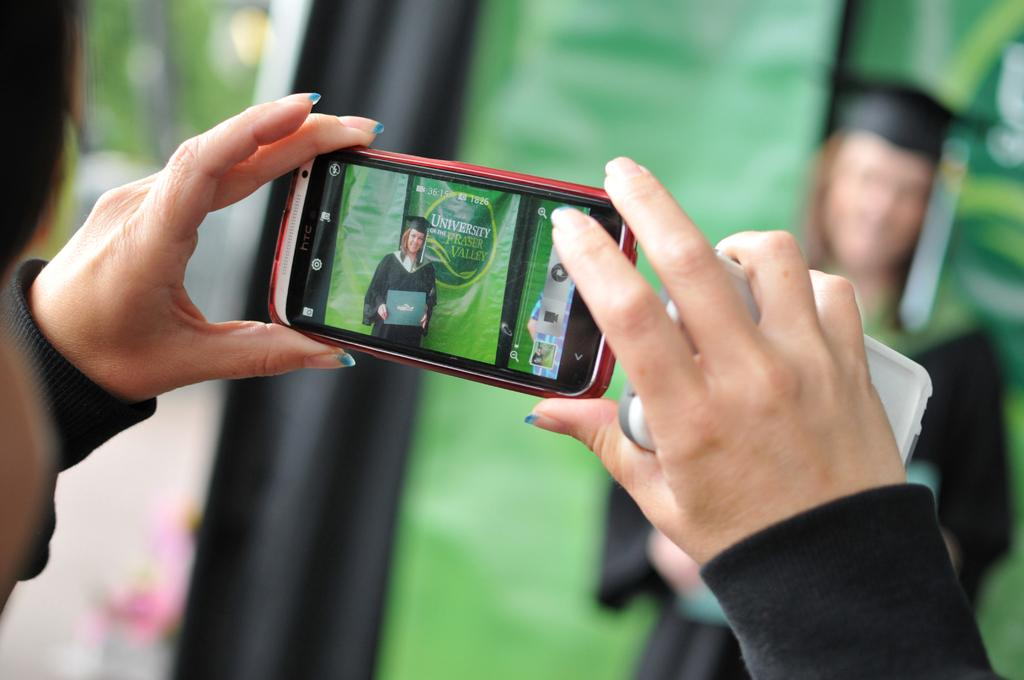<image>
Render a clear and concise summary of the photo. A man is taking a picture of a graduate from University of Frasier Valley. 